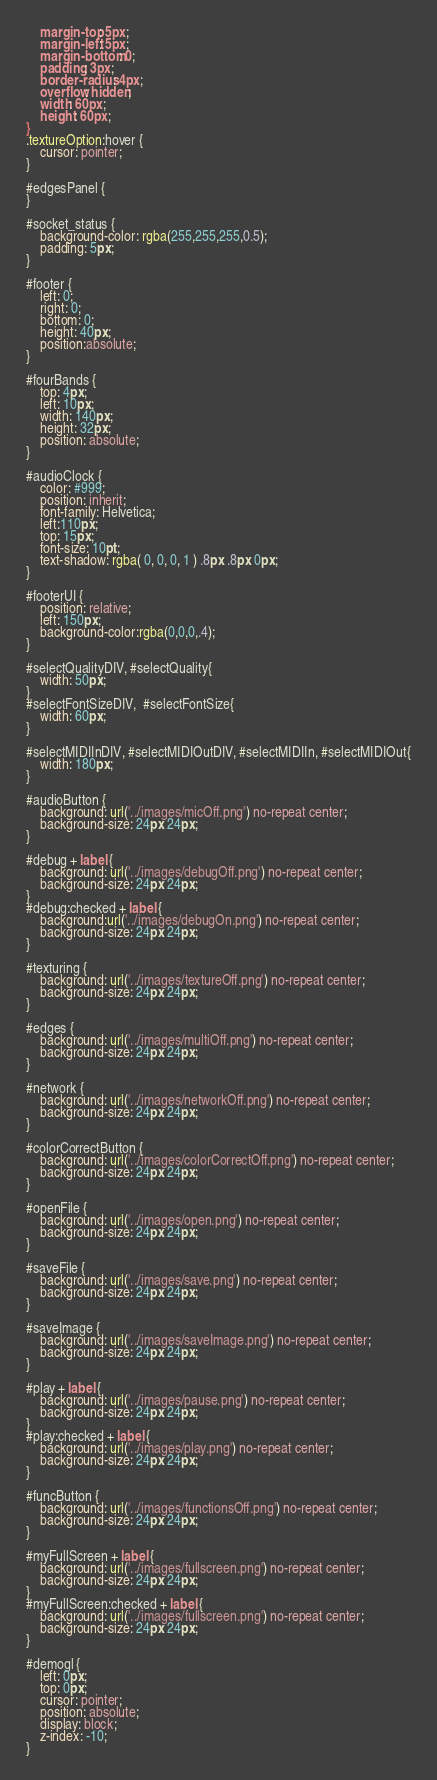<code> <loc_0><loc_0><loc_500><loc_500><_CSS_>    margin-top: 5px;
    margin-left: 5px;
    margin-bottom: 0;
    padding: 3px;
    border-radius: 4px;
    overflow: hidden;
    width: 60px;
    height: 60px;
}
.textureOption:hover {
    cursor: pointer;
}

#edgesPanel {
}

#socket_status {
    background-color: rgba(255,255,255,0.5);
    padding: 5px;
}

#footer {
    left: 0;
    right: 0;
    bottom: 0;
    height: 40px;
    position:absolute;    
}

#fourBands {
    top: 4px;
    left: 10px;
    width: 140px;
    height: 32px;
    position: absolute;
}

#audioClock {
    color: #999;
    position: inherit;
    font-family: Helvetica;
    left:110px;
    top: 15px;
    font-size: 10pt;
    text-shadow: rgba( 0, 0, 0, 1 ) .8px .8px 0px;
}

#footerUI {
    position: relative;
    left: 150px;
    background-color:rgba(0,0,0,.4);
}

#selectQualityDIV, #selectQuality{
    width: 50px;
} 
#selectFontSizeDIV,  #selectFontSize{
    width: 60px;
}

#selectMIDIInDIV, #selectMIDIOutDIV, #selectMIDIIn, #selectMIDIOut{
    width: 180px;
}

#audioButton {
    background: url('../images/micOff.png') no-repeat center;
    background-size: 24px 24px;
}

#debug + label {
    background: url('../images/debugOff.png') no-repeat center;
    background-size: 24px 24px;
}
#debug:checked + label {
    background:url('../images/debugOn.png') no-repeat center;
    background-size: 24px 24px;
}

#texturing {
    background: url('../images/textureOff.png') no-repeat center;
    background-size: 24px 24px;
}

#edges {
    background: url('../images/multiOff.png') no-repeat center;
    background-size: 24px 24px;
}

#network {
    background: url('../images/networkOff.png') no-repeat center;
    background-size: 24px 24px;
}

#colorCorrectButton {
    background: url('../images/colorCorrectOff.png') no-repeat center;
    background-size: 24px 24px;
}

#openFile {
    background: url('../images/open.png') no-repeat center;
    background-size: 24px 24px;
}

#saveFile {
    background: url('../images/save.png') no-repeat center;
    background-size: 24px 24px;
}

#saveImage {
    background: url('../images/saveImage.png') no-repeat center;
    background-size: 24px 24px;
}

#play + label {
    background: url('../images/pause.png') no-repeat center;
    background-size: 24px 24px;
}
#play:checked + label {
    background: url('../images/play.png') no-repeat center;
    background-size: 24px 24px;
}

#funcButton {
    background: url('../images/functionsOff.png') no-repeat center;
    background-size: 24px 24px;
}

#myFullScreen + label {
    background: url('../images/fullscreen.png') no-repeat center;
    background-size: 24px 24px;
}
#myFullScreen:checked + label {
    background: url('../images/fullscreen.png') no-repeat center;
    background-size: 24px 24px;
}

#demogl {
    left: 0px;
    top: 0px;
    cursor: pointer;
    position: absolute;
    display: block;
    z-index: -10;
}
</code> 